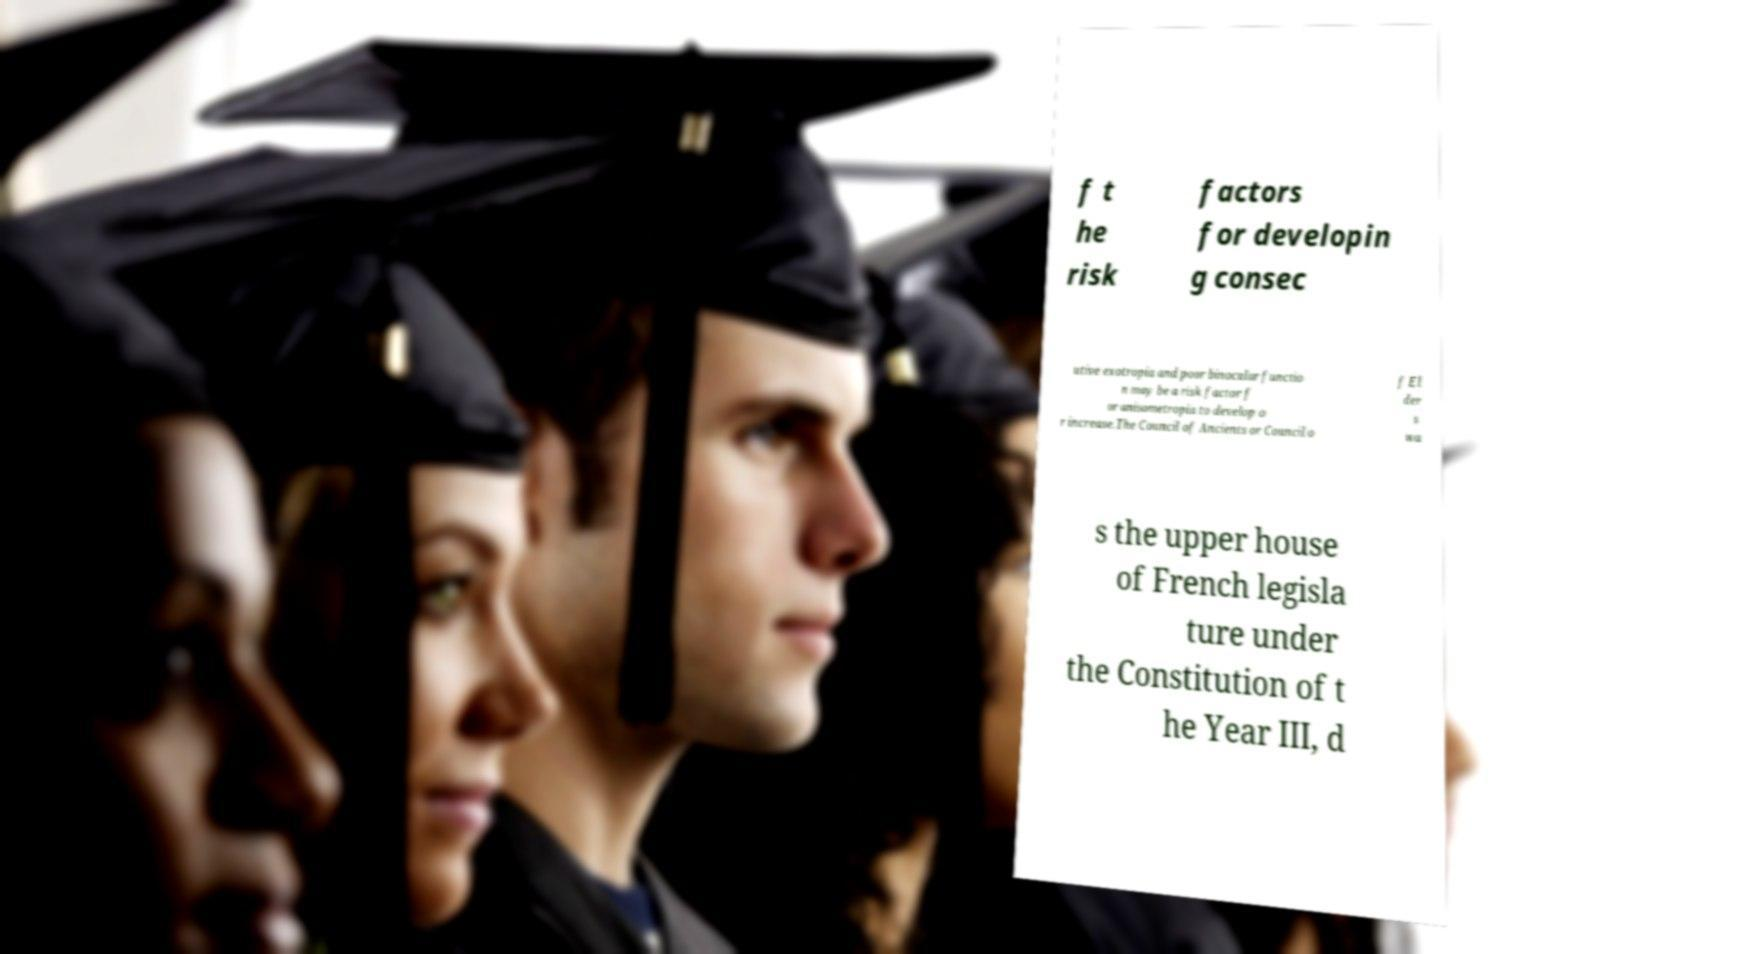For documentation purposes, I need the text within this image transcribed. Could you provide that? f t he risk factors for developin g consec utive exotropia and poor binocular functio n may be a risk factor f or anisometropia to develop o r increase.The Council of Ancients or Council o f El der s wa s the upper house of French legisla ture under the Constitution of t he Year III, d 